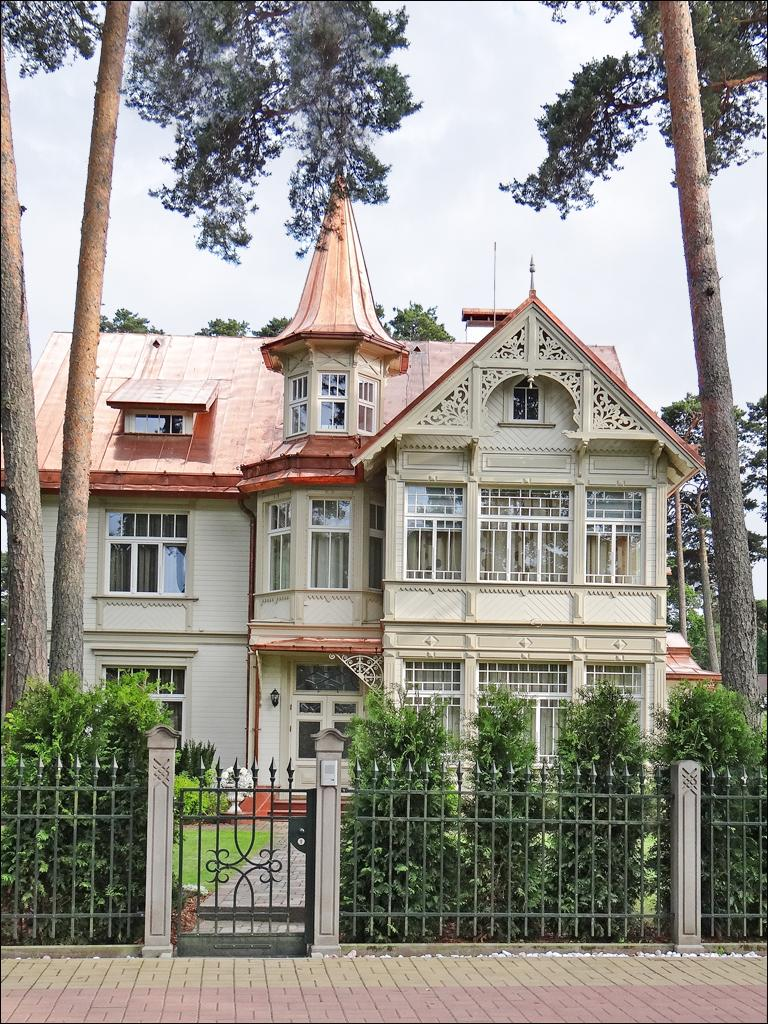What is located in the foreground of the image? There is a fence, plants, grass, and a building in the foreground of the image. What type of vegetation can be seen in the foreground? There are plants and grass in the foreground of the image. What is visible in the background of the image? There are trees and the sky visible in the background of the image. Can you describe the time of day when the image was taken? The image was taken during the day. What word is written on the fence in the image? There is no word written on the fence in the image. How many toes can be seen on the person in the image? There is no person present in the image, so no toes can be seen. 